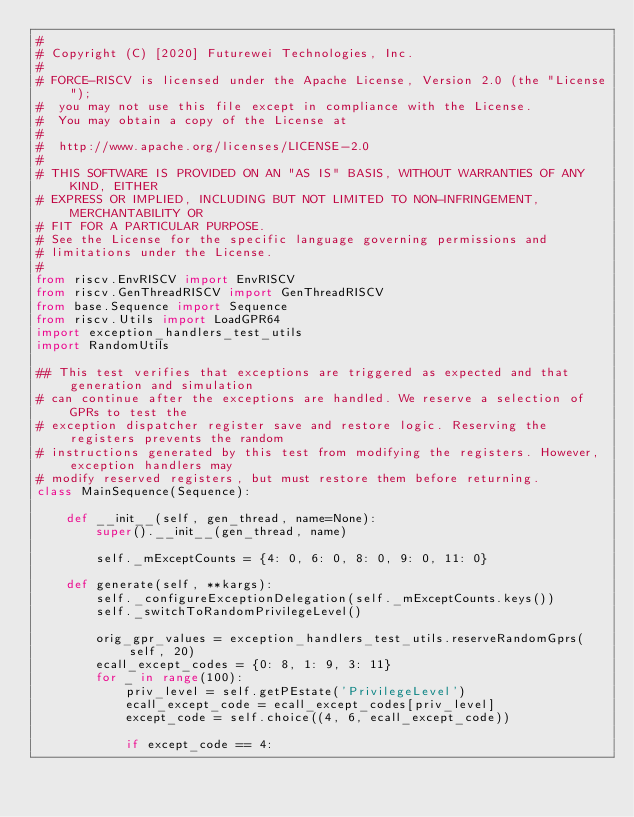<code> <loc_0><loc_0><loc_500><loc_500><_Python_>#
# Copyright (C) [2020] Futurewei Technologies, Inc.
#
# FORCE-RISCV is licensed under the Apache License, Version 2.0 (the "License");
#  you may not use this file except in compliance with the License.
#  You may obtain a copy of the License at
#
#  http://www.apache.org/licenses/LICENSE-2.0
#
# THIS SOFTWARE IS PROVIDED ON AN "AS IS" BASIS, WITHOUT WARRANTIES OF ANY KIND, EITHER
# EXPRESS OR IMPLIED, INCLUDING BUT NOT LIMITED TO NON-INFRINGEMENT, MERCHANTABILITY OR
# FIT FOR A PARTICULAR PURPOSE.
# See the License for the specific language governing permissions and
# limitations under the License.
#
from riscv.EnvRISCV import EnvRISCV
from riscv.GenThreadRISCV import GenThreadRISCV
from base.Sequence import Sequence
from riscv.Utils import LoadGPR64
import exception_handlers_test_utils
import RandomUtils

## This test verifies that exceptions are triggered as expected and that generation and simulation
# can continue after the exceptions are handled. We reserve a selection of GPRs to test the
# exception dispatcher register save and restore logic. Reserving the registers prevents the random
# instructions generated by this test from modifying the registers. However, exception handlers may
# modify reserved registers, but must restore them before returning.
class MainSequence(Sequence):

    def __init__(self, gen_thread, name=None):
        super().__init__(gen_thread, name)

        self._mExceptCounts = {4: 0, 6: 0, 8: 0, 9: 0, 11: 0}

    def generate(self, **kargs):
        self._configureExceptionDelegation(self._mExceptCounts.keys())
        self._switchToRandomPrivilegeLevel()

        orig_gpr_values = exception_handlers_test_utils.reserveRandomGprs(self, 20)
        ecall_except_codes = {0: 8, 1: 9, 3: 11}
        for _ in range(100):
            priv_level = self.getPEstate('PrivilegeLevel')
            ecall_except_code = ecall_except_codes[priv_level]
            except_code = self.choice((4, 6, ecall_except_code))

            if except_code == 4:</code> 